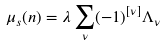<formula> <loc_0><loc_0><loc_500><loc_500>\mu _ { s } ( { n } ) = \lambda \sum _ { \nu } ( - 1 ) ^ { [ \nu ] } \Lambda _ { \nu }</formula> 